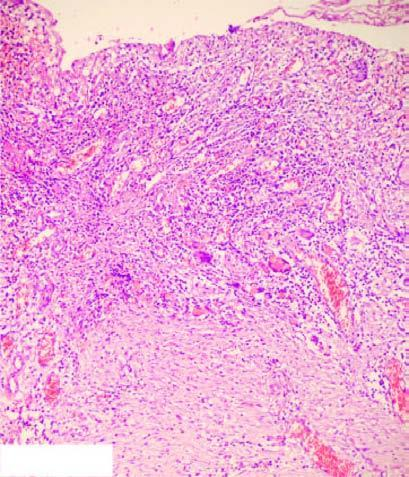re chematic representation of mechanisms illustrated in the diagram?
Answer the question using a single word or phrase. No 